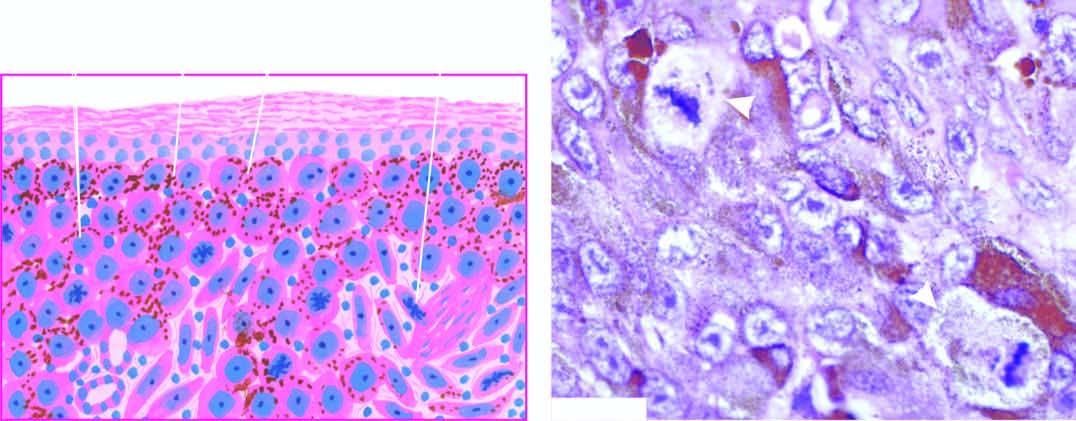what do many of the tumour cells contain?
Answer the question using a single word or phrase. Fine granular melanin pigment 